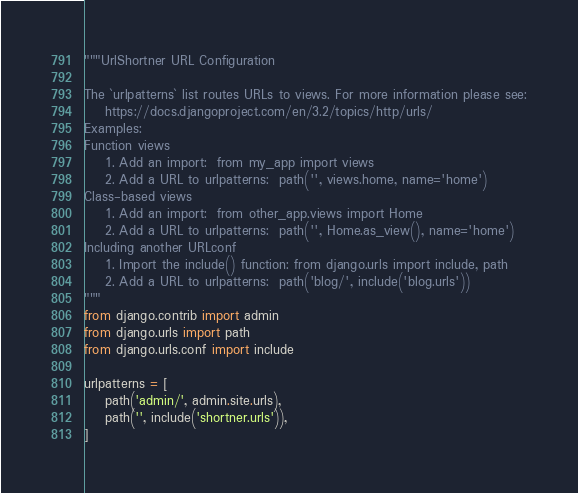Convert code to text. <code><loc_0><loc_0><loc_500><loc_500><_Python_>"""UrlShortner URL Configuration

The `urlpatterns` list routes URLs to views. For more information please see:
    https://docs.djangoproject.com/en/3.2/topics/http/urls/
Examples:
Function views
    1. Add an import:  from my_app import views
    2. Add a URL to urlpatterns:  path('', views.home, name='home')
Class-based views
    1. Add an import:  from other_app.views import Home
    2. Add a URL to urlpatterns:  path('', Home.as_view(), name='home')
Including another URLconf
    1. Import the include() function: from django.urls import include, path
    2. Add a URL to urlpatterns:  path('blog/', include('blog.urls'))
"""
from django.contrib import admin
from django.urls import path
from django.urls.conf import include

urlpatterns = [
    path('admin/', admin.site.urls),
    path('', include('shortner.urls')),
]
</code> 